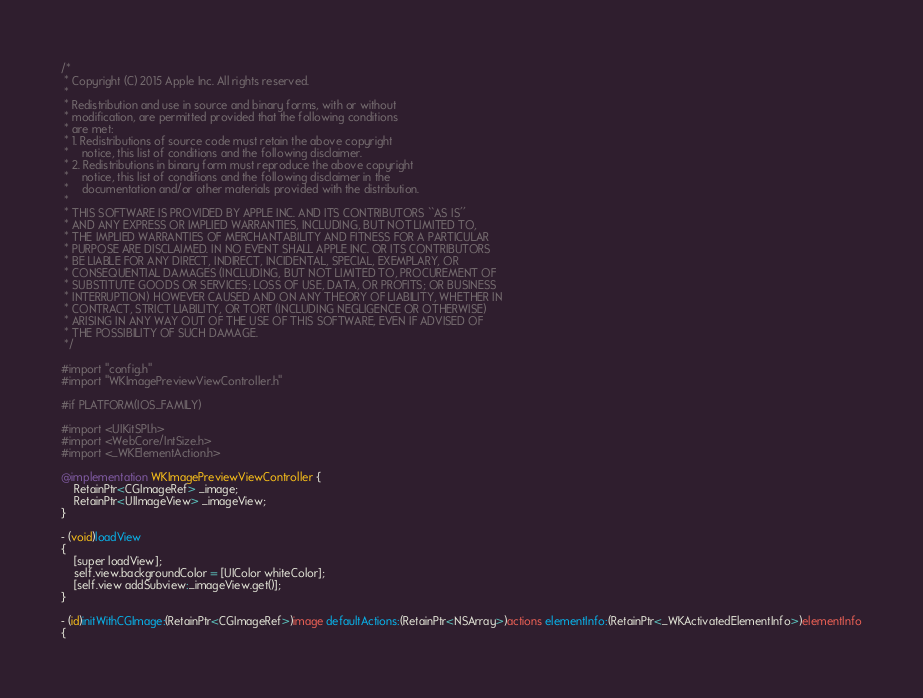Convert code to text. <code><loc_0><loc_0><loc_500><loc_500><_ObjectiveC_>/*
 * Copyright (C) 2015 Apple Inc. All rights reserved.
 *
 * Redistribution and use in source and binary forms, with or without
 * modification, are permitted provided that the following conditions
 * are met:
 * 1. Redistributions of source code must retain the above copyright
 *    notice, this list of conditions and the following disclaimer.
 * 2. Redistributions in binary form must reproduce the above copyright
 *    notice, this list of conditions and the following disclaimer in the
 *    documentation and/or other materials provided with the distribution.
 *
 * THIS SOFTWARE IS PROVIDED BY APPLE INC. AND ITS CONTRIBUTORS ``AS IS''
 * AND ANY EXPRESS OR IMPLIED WARRANTIES, INCLUDING, BUT NOT LIMITED TO,
 * THE IMPLIED WARRANTIES OF MERCHANTABILITY AND FITNESS FOR A PARTICULAR
 * PURPOSE ARE DISCLAIMED. IN NO EVENT SHALL APPLE INC. OR ITS CONTRIBUTORS
 * BE LIABLE FOR ANY DIRECT, INDIRECT, INCIDENTAL, SPECIAL, EXEMPLARY, OR
 * CONSEQUENTIAL DAMAGES (INCLUDING, BUT NOT LIMITED TO, PROCUREMENT OF
 * SUBSTITUTE GOODS OR SERVICES; LOSS OF USE, DATA, OR PROFITS; OR BUSINESS
 * INTERRUPTION) HOWEVER CAUSED AND ON ANY THEORY OF LIABILITY, WHETHER IN
 * CONTRACT, STRICT LIABILITY, OR TORT (INCLUDING NEGLIGENCE OR OTHERWISE)
 * ARISING IN ANY WAY OUT OF THE USE OF THIS SOFTWARE, EVEN IF ADVISED OF
 * THE POSSIBILITY OF SUCH DAMAGE.
 */

#import "config.h"
#import "WKImagePreviewViewController.h"

#if PLATFORM(IOS_FAMILY)

#import <UIKitSPI.h>
#import <WebCore/IntSize.h>
#import <_WKElementAction.h>

@implementation WKImagePreviewViewController {
    RetainPtr<CGImageRef> _image;
    RetainPtr<UIImageView> _imageView;
}

- (void)loadView
{
    [super loadView];
    self.view.backgroundColor = [UIColor whiteColor];
    [self.view addSubview:_imageView.get()];
}

- (id)initWithCGImage:(RetainPtr<CGImageRef>)image defaultActions:(RetainPtr<NSArray>)actions elementInfo:(RetainPtr<_WKActivatedElementInfo>)elementInfo
{</code> 